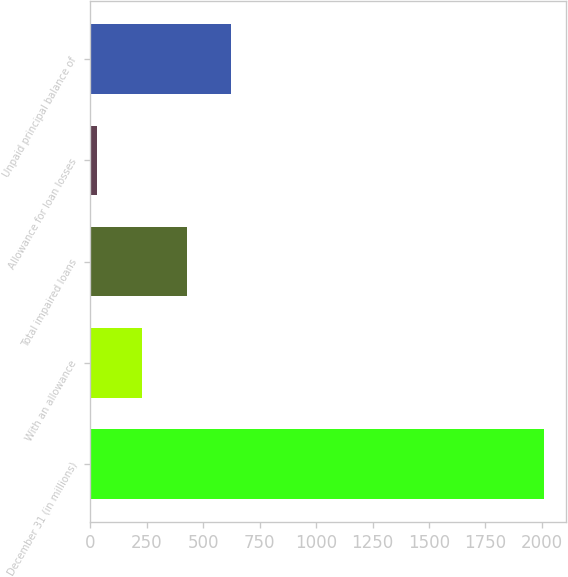Convert chart to OTSL. <chart><loc_0><loc_0><loc_500><loc_500><bar_chart><fcel>December 31 (in millions)<fcel>With an allowance<fcel>Total impaired loans<fcel>Allowance for loan losses<fcel>Unpaid principal balance of<nl><fcel>2009<fcel>227.9<fcel>425.8<fcel>30<fcel>623.7<nl></chart> 